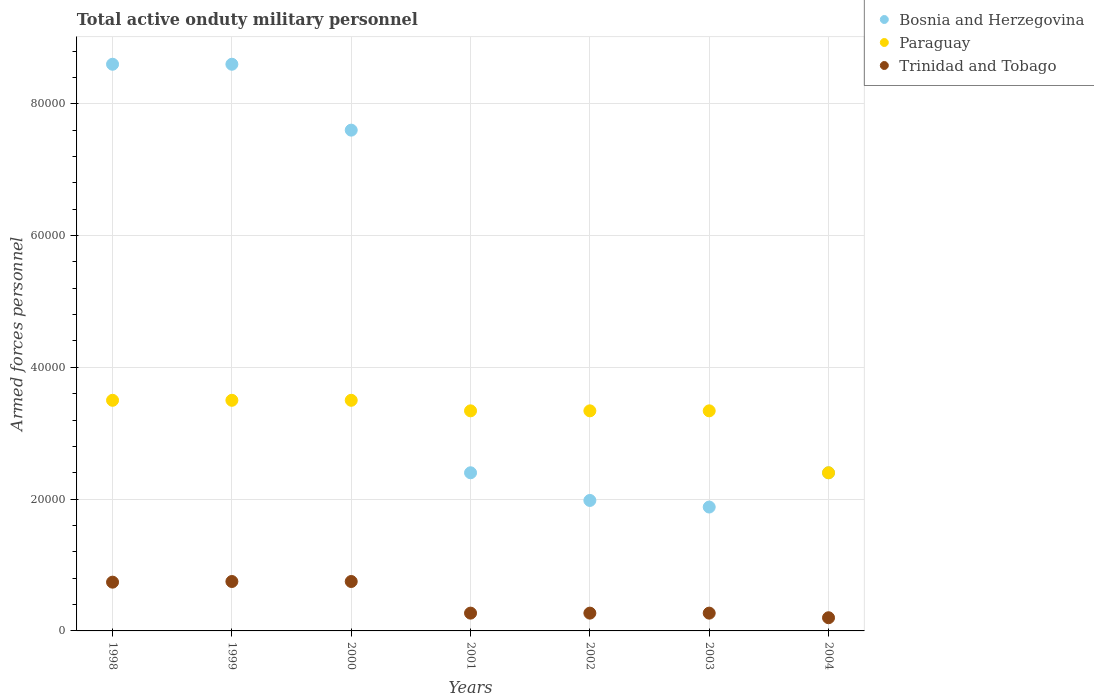What is the number of armed forces personnel in Trinidad and Tobago in 2000?
Offer a very short reply. 7500. Across all years, what is the maximum number of armed forces personnel in Paraguay?
Offer a very short reply. 3.50e+04. Across all years, what is the minimum number of armed forces personnel in Trinidad and Tobago?
Provide a succinct answer. 2000. In which year was the number of armed forces personnel in Paraguay maximum?
Your response must be concise. 1998. In which year was the number of armed forces personnel in Bosnia and Herzegovina minimum?
Provide a succinct answer. 2003. What is the total number of armed forces personnel in Paraguay in the graph?
Keep it short and to the point. 2.29e+05. What is the difference between the number of armed forces personnel in Paraguay in 2000 and that in 2004?
Make the answer very short. 1.10e+04. What is the difference between the number of armed forces personnel in Bosnia and Herzegovina in 1998 and the number of armed forces personnel in Trinidad and Tobago in 2004?
Offer a terse response. 8.40e+04. What is the average number of armed forces personnel in Bosnia and Herzegovina per year?
Give a very brief answer. 4.78e+04. In how many years, is the number of armed forces personnel in Bosnia and Herzegovina greater than 64000?
Your response must be concise. 3. What is the ratio of the number of armed forces personnel in Bosnia and Herzegovina in 2001 to that in 2003?
Offer a terse response. 1.28. Is the number of armed forces personnel in Paraguay in 1998 less than that in 1999?
Ensure brevity in your answer.  No. Is the difference between the number of armed forces personnel in Paraguay in 1999 and 2001 greater than the difference between the number of armed forces personnel in Bosnia and Herzegovina in 1999 and 2001?
Provide a short and direct response. No. What is the difference between the highest and the lowest number of armed forces personnel in Bosnia and Herzegovina?
Your answer should be compact. 6.72e+04. In how many years, is the number of armed forces personnel in Bosnia and Herzegovina greater than the average number of armed forces personnel in Bosnia and Herzegovina taken over all years?
Your answer should be very brief. 3. Does the number of armed forces personnel in Bosnia and Herzegovina monotonically increase over the years?
Offer a terse response. No. Is the number of armed forces personnel in Paraguay strictly greater than the number of armed forces personnel in Bosnia and Herzegovina over the years?
Your answer should be compact. No. How many dotlines are there?
Keep it short and to the point. 3. How many years are there in the graph?
Offer a terse response. 7. Are the values on the major ticks of Y-axis written in scientific E-notation?
Your answer should be very brief. No. Does the graph contain grids?
Your response must be concise. Yes. Where does the legend appear in the graph?
Provide a short and direct response. Top right. How are the legend labels stacked?
Your answer should be very brief. Vertical. What is the title of the graph?
Keep it short and to the point. Total active onduty military personnel. Does "Ethiopia" appear as one of the legend labels in the graph?
Provide a short and direct response. No. What is the label or title of the X-axis?
Your response must be concise. Years. What is the label or title of the Y-axis?
Your answer should be compact. Armed forces personnel. What is the Armed forces personnel of Bosnia and Herzegovina in 1998?
Make the answer very short. 8.60e+04. What is the Armed forces personnel in Paraguay in 1998?
Give a very brief answer. 3.50e+04. What is the Armed forces personnel in Trinidad and Tobago in 1998?
Offer a terse response. 7400. What is the Armed forces personnel of Bosnia and Herzegovina in 1999?
Your answer should be compact. 8.60e+04. What is the Armed forces personnel in Paraguay in 1999?
Your response must be concise. 3.50e+04. What is the Armed forces personnel of Trinidad and Tobago in 1999?
Provide a short and direct response. 7500. What is the Armed forces personnel in Bosnia and Herzegovina in 2000?
Your response must be concise. 7.60e+04. What is the Armed forces personnel of Paraguay in 2000?
Ensure brevity in your answer.  3.50e+04. What is the Armed forces personnel in Trinidad and Tobago in 2000?
Keep it short and to the point. 7500. What is the Armed forces personnel of Bosnia and Herzegovina in 2001?
Give a very brief answer. 2.40e+04. What is the Armed forces personnel of Paraguay in 2001?
Provide a succinct answer. 3.34e+04. What is the Armed forces personnel of Trinidad and Tobago in 2001?
Give a very brief answer. 2700. What is the Armed forces personnel in Bosnia and Herzegovina in 2002?
Offer a terse response. 1.98e+04. What is the Armed forces personnel of Paraguay in 2002?
Provide a short and direct response. 3.34e+04. What is the Armed forces personnel in Trinidad and Tobago in 2002?
Provide a short and direct response. 2700. What is the Armed forces personnel in Bosnia and Herzegovina in 2003?
Provide a succinct answer. 1.88e+04. What is the Armed forces personnel in Paraguay in 2003?
Give a very brief answer. 3.34e+04. What is the Armed forces personnel in Trinidad and Tobago in 2003?
Provide a short and direct response. 2700. What is the Armed forces personnel of Bosnia and Herzegovina in 2004?
Provide a succinct answer. 2.40e+04. What is the Armed forces personnel of Paraguay in 2004?
Offer a terse response. 2.40e+04. Across all years, what is the maximum Armed forces personnel of Bosnia and Herzegovina?
Your response must be concise. 8.60e+04. Across all years, what is the maximum Armed forces personnel in Paraguay?
Give a very brief answer. 3.50e+04. Across all years, what is the maximum Armed forces personnel of Trinidad and Tobago?
Make the answer very short. 7500. Across all years, what is the minimum Armed forces personnel of Bosnia and Herzegovina?
Offer a terse response. 1.88e+04. Across all years, what is the minimum Armed forces personnel in Paraguay?
Provide a short and direct response. 2.40e+04. What is the total Armed forces personnel of Bosnia and Herzegovina in the graph?
Give a very brief answer. 3.35e+05. What is the total Armed forces personnel in Paraguay in the graph?
Your answer should be compact. 2.29e+05. What is the total Armed forces personnel of Trinidad and Tobago in the graph?
Ensure brevity in your answer.  3.25e+04. What is the difference between the Armed forces personnel in Trinidad and Tobago in 1998 and that in 1999?
Make the answer very short. -100. What is the difference between the Armed forces personnel of Bosnia and Herzegovina in 1998 and that in 2000?
Offer a terse response. 10000. What is the difference between the Armed forces personnel in Trinidad and Tobago in 1998 and that in 2000?
Your answer should be very brief. -100. What is the difference between the Armed forces personnel in Bosnia and Herzegovina in 1998 and that in 2001?
Provide a short and direct response. 6.20e+04. What is the difference between the Armed forces personnel in Paraguay in 1998 and that in 2001?
Ensure brevity in your answer.  1600. What is the difference between the Armed forces personnel in Trinidad and Tobago in 1998 and that in 2001?
Offer a terse response. 4700. What is the difference between the Armed forces personnel in Bosnia and Herzegovina in 1998 and that in 2002?
Offer a very short reply. 6.62e+04. What is the difference between the Armed forces personnel of Paraguay in 1998 and that in 2002?
Provide a short and direct response. 1600. What is the difference between the Armed forces personnel in Trinidad and Tobago in 1998 and that in 2002?
Your response must be concise. 4700. What is the difference between the Armed forces personnel of Bosnia and Herzegovina in 1998 and that in 2003?
Provide a short and direct response. 6.72e+04. What is the difference between the Armed forces personnel in Paraguay in 1998 and that in 2003?
Provide a succinct answer. 1600. What is the difference between the Armed forces personnel in Trinidad and Tobago in 1998 and that in 2003?
Your answer should be compact. 4700. What is the difference between the Armed forces personnel in Bosnia and Herzegovina in 1998 and that in 2004?
Your response must be concise. 6.20e+04. What is the difference between the Armed forces personnel of Paraguay in 1998 and that in 2004?
Provide a succinct answer. 1.10e+04. What is the difference between the Armed forces personnel in Trinidad and Tobago in 1998 and that in 2004?
Your answer should be very brief. 5400. What is the difference between the Armed forces personnel of Paraguay in 1999 and that in 2000?
Provide a short and direct response. 0. What is the difference between the Armed forces personnel in Bosnia and Herzegovina in 1999 and that in 2001?
Your answer should be very brief. 6.20e+04. What is the difference between the Armed forces personnel in Paraguay in 1999 and that in 2001?
Your response must be concise. 1600. What is the difference between the Armed forces personnel in Trinidad and Tobago in 1999 and that in 2001?
Make the answer very short. 4800. What is the difference between the Armed forces personnel in Bosnia and Herzegovina in 1999 and that in 2002?
Give a very brief answer. 6.62e+04. What is the difference between the Armed forces personnel in Paraguay in 1999 and that in 2002?
Your answer should be compact. 1600. What is the difference between the Armed forces personnel in Trinidad and Tobago in 1999 and that in 2002?
Make the answer very short. 4800. What is the difference between the Armed forces personnel of Bosnia and Herzegovina in 1999 and that in 2003?
Your answer should be very brief. 6.72e+04. What is the difference between the Armed forces personnel in Paraguay in 1999 and that in 2003?
Your response must be concise. 1600. What is the difference between the Armed forces personnel in Trinidad and Tobago in 1999 and that in 2003?
Offer a very short reply. 4800. What is the difference between the Armed forces personnel in Bosnia and Herzegovina in 1999 and that in 2004?
Make the answer very short. 6.20e+04. What is the difference between the Armed forces personnel of Paraguay in 1999 and that in 2004?
Your answer should be compact. 1.10e+04. What is the difference between the Armed forces personnel of Trinidad and Tobago in 1999 and that in 2004?
Ensure brevity in your answer.  5500. What is the difference between the Armed forces personnel of Bosnia and Herzegovina in 2000 and that in 2001?
Your response must be concise. 5.20e+04. What is the difference between the Armed forces personnel in Paraguay in 2000 and that in 2001?
Your response must be concise. 1600. What is the difference between the Armed forces personnel in Trinidad and Tobago in 2000 and that in 2001?
Provide a succinct answer. 4800. What is the difference between the Armed forces personnel of Bosnia and Herzegovina in 2000 and that in 2002?
Provide a short and direct response. 5.62e+04. What is the difference between the Armed forces personnel of Paraguay in 2000 and that in 2002?
Provide a succinct answer. 1600. What is the difference between the Armed forces personnel in Trinidad and Tobago in 2000 and that in 2002?
Your answer should be very brief. 4800. What is the difference between the Armed forces personnel of Bosnia and Herzegovina in 2000 and that in 2003?
Your answer should be very brief. 5.72e+04. What is the difference between the Armed forces personnel in Paraguay in 2000 and that in 2003?
Offer a terse response. 1600. What is the difference between the Armed forces personnel in Trinidad and Tobago in 2000 and that in 2003?
Provide a succinct answer. 4800. What is the difference between the Armed forces personnel of Bosnia and Herzegovina in 2000 and that in 2004?
Provide a succinct answer. 5.20e+04. What is the difference between the Armed forces personnel of Paraguay in 2000 and that in 2004?
Your answer should be compact. 1.10e+04. What is the difference between the Armed forces personnel in Trinidad and Tobago in 2000 and that in 2004?
Your response must be concise. 5500. What is the difference between the Armed forces personnel of Bosnia and Herzegovina in 2001 and that in 2002?
Provide a short and direct response. 4200. What is the difference between the Armed forces personnel of Paraguay in 2001 and that in 2002?
Provide a short and direct response. 0. What is the difference between the Armed forces personnel of Bosnia and Herzegovina in 2001 and that in 2003?
Offer a terse response. 5200. What is the difference between the Armed forces personnel in Paraguay in 2001 and that in 2003?
Provide a succinct answer. 0. What is the difference between the Armed forces personnel in Paraguay in 2001 and that in 2004?
Offer a very short reply. 9400. What is the difference between the Armed forces personnel of Trinidad and Tobago in 2001 and that in 2004?
Your response must be concise. 700. What is the difference between the Armed forces personnel of Bosnia and Herzegovina in 2002 and that in 2004?
Your response must be concise. -4200. What is the difference between the Armed forces personnel in Paraguay in 2002 and that in 2004?
Give a very brief answer. 9400. What is the difference between the Armed forces personnel in Trinidad and Tobago in 2002 and that in 2004?
Give a very brief answer. 700. What is the difference between the Armed forces personnel of Bosnia and Herzegovina in 2003 and that in 2004?
Offer a terse response. -5200. What is the difference between the Armed forces personnel in Paraguay in 2003 and that in 2004?
Provide a short and direct response. 9400. What is the difference between the Armed forces personnel in Trinidad and Tobago in 2003 and that in 2004?
Provide a short and direct response. 700. What is the difference between the Armed forces personnel in Bosnia and Herzegovina in 1998 and the Armed forces personnel in Paraguay in 1999?
Your response must be concise. 5.10e+04. What is the difference between the Armed forces personnel of Bosnia and Herzegovina in 1998 and the Armed forces personnel of Trinidad and Tobago in 1999?
Provide a succinct answer. 7.85e+04. What is the difference between the Armed forces personnel of Paraguay in 1998 and the Armed forces personnel of Trinidad and Tobago in 1999?
Your answer should be very brief. 2.75e+04. What is the difference between the Armed forces personnel in Bosnia and Herzegovina in 1998 and the Armed forces personnel in Paraguay in 2000?
Provide a succinct answer. 5.10e+04. What is the difference between the Armed forces personnel in Bosnia and Herzegovina in 1998 and the Armed forces personnel in Trinidad and Tobago in 2000?
Your answer should be compact. 7.85e+04. What is the difference between the Armed forces personnel in Paraguay in 1998 and the Armed forces personnel in Trinidad and Tobago in 2000?
Offer a terse response. 2.75e+04. What is the difference between the Armed forces personnel in Bosnia and Herzegovina in 1998 and the Armed forces personnel in Paraguay in 2001?
Provide a succinct answer. 5.26e+04. What is the difference between the Armed forces personnel of Bosnia and Herzegovina in 1998 and the Armed forces personnel of Trinidad and Tobago in 2001?
Provide a succinct answer. 8.33e+04. What is the difference between the Armed forces personnel in Paraguay in 1998 and the Armed forces personnel in Trinidad and Tobago in 2001?
Provide a succinct answer. 3.23e+04. What is the difference between the Armed forces personnel of Bosnia and Herzegovina in 1998 and the Armed forces personnel of Paraguay in 2002?
Your response must be concise. 5.26e+04. What is the difference between the Armed forces personnel in Bosnia and Herzegovina in 1998 and the Armed forces personnel in Trinidad and Tobago in 2002?
Offer a very short reply. 8.33e+04. What is the difference between the Armed forces personnel of Paraguay in 1998 and the Armed forces personnel of Trinidad and Tobago in 2002?
Your answer should be very brief. 3.23e+04. What is the difference between the Armed forces personnel in Bosnia and Herzegovina in 1998 and the Armed forces personnel in Paraguay in 2003?
Your response must be concise. 5.26e+04. What is the difference between the Armed forces personnel of Bosnia and Herzegovina in 1998 and the Armed forces personnel of Trinidad and Tobago in 2003?
Your response must be concise. 8.33e+04. What is the difference between the Armed forces personnel in Paraguay in 1998 and the Armed forces personnel in Trinidad and Tobago in 2003?
Ensure brevity in your answer.  3.23e+04. What is the difference between the Armed forces personnel of Bosnia and Herzegovina in 1998 and the Armed forces personnel of Paraguay in 2004?
Make the answer very short. 6.20e+04. What is the difference between the Armed forces personnel of Bosnia and Herzegovina in 1998 and the Armed forces personnel of Trinidad and Tobago in 2004?
Ensure brevity in your answer.  8.40e+04. What is the difference between the Armed forces personnel in Paraguay in 1998 and the Armed forces personnel in Trinidad and Tobago in 2004?
Offer a very short reply. 3.30e+04. What is the difference between the Armed forces personnel in Bosnia and Herzegovina in 1999 and the Armed forces personnel in Paraguay in 2000?
Keep it short and to the point. 5.10e+04. What is the difference between the Armed forces personnel of Bosnia and Herzegovina in 1999 and the Armed forces personnel of Trinidad and Tobago in 2000?
Provide a short and direct response. 7.85e+04. What is the difference between the Armed forces personnel in Paraguay in 1999 and the Armed forces personnel in Trinidad and Tobago in 2000?
Provide a short and direct response. 2.75e+04. What is the difference between the Armed forces personnel in Bosnia and Herzegovina in 1999 and the Armed forces personnel in Paraguay in 2001?
Give a very brief answer. 5.26e+04. What is the difference between the Armed forces personnel of Bosnia and Herzegovina in 1999 and the Armed forces personnel of Trinidad and Tobago in 2001?
Your response must be concise. 8.33e+04. What is the difference between the Armed forces personnel of Paraguay in 1999 and the Armed forces personnel of Trinidad and Tobago in 2001?
Give a very brief answer. 3.23e+04. What is the difference between the Armed forces personnel in Bosnia and Herzegovina in 1999 and the Armed forces personnel in Paraguay in 2002?
Your response must be concise. 5.26e+04. What is the difference between the Armed forces personnel in Bosnia and Herzegovina in 1999 and the Armed forces personnel in Trinidad and Tobago in 2002?
Keep it short and to the point. 8.33e+04. What is the difference between the Armed forces personnel of Paraguay in 1999 and the Armed forces personnel of Trinidad and Tobago in 2002?
Ensure brevity in your answer.  3.23e+04. What is the difference between the Armed forces personnel in Bosnia and Herzegovina in 1999 and the Armed forces personnel in Paraguay in 2003?
Your answer should be very brief. 5.26e+04. What is the difference between the Armed forces personnel in Bosnia and Herzegovina in 1999 and the Armed forces personnel in Trinidad and Tobago in 2003?
Keep it short and to the point. 8.33e+04. What is the difference between the Armed forces personnel of Paraguay in 1999 and the Armed forces personnel of Trinidad and Tobago in 2003?
Provide a succinct answer. 3.23e+04. What is the difference between the Armed forces personnel in Bosnia and Herzegovina in 1999 and the Armed forces personnel in Paraguay in 2004?
Your response must be concise. 6.20e+04. What is the difference between the Armed forces personnel in Bosnia and Herzegovina in 1999 and the Armed forces personnel in Trinidad and Tobago in 2004?
Your answer should be very brief. 8.40e+04. What is the difference between the Armed forces personnel of Paraguay in 1999 and the Armed forces personnel of Trinidad and Tobago in 2004?
Your answer should be compact. 3.30e+04. What is the difference between the Armed forces personnel of Bosnia and Herzegovina in 2000 and the Armed forces personnel of Paraguay in 2001?
Make the answer very short. 4.26e+04. What is the difference between the Armed forces personnel in Bosnia and Herzegovina in 2000 and the Armed forces personnel in Trinidad and Tobago in 2001?
Your answer should be very brief. 7.33e+04. What is the difference between the Armed forces personnel of Paraguay in 2000 and the Armed forces personnel of Trinidad and Tobago in 2001?
Your response must be concise. 3.23e+04. What is the difference between the Armed forces personnel in Bosnia and Herzegovina in 2000 and the Armed forces personnel in Paraguay in 2002?
Keep it short and to the point. 4.26e+04. What is the difference between the Armed forces personnel in Bosnia and Herzegovina in 2000 and the Armed forces personnel in Trinidad and Tobago in 2002?
Keep it short and to the point. 7.33e+04. What is the difference between the Armed forces personnel of Paraguay in 2000 and the Armed forces personnel of Trinidad and Tobago in 2002?
Your response must be concise. 3.23e+04. What is the difference between the Armed forces personnel in Bosnia and Herzegovina in 2000 and the Armed forces personnel in Paraguay in 2003?
Your response must be concise. 4.26e+04. What is the difference between the Armed forces personnel in Bosnia and Herzegovina in 2000 and the Armed forces personnel in Trinidad and Tobago in 2003?
Your response must be concise. 7.33e+04. What is the difference between the Armed forces personnel of Paraguay in 2000 and the Armed forces personnel of Trinidad and Tobago in 2003?
Your answer should be very brief. 3.23e+04. What is the difference between the Armed forces personnel of Bosnia and Herzegovina in 2000 and the Armed forces personnel of Paraguay in 2004?
Offer a very short reply. 5.20e+04. What is the difference between the Armed forces personnel in Bosnia and Herzegovina in 2000 and the Armed forces personnel in Trinidad and Tobago in 2004?
Make the answer very short. 7.40e+04. What is the difference between the Armed forces personnel in Paraguay in 2000 and the Armed forces personnel in Trinidad and Tobago in 2004?
Your response must be concise. 3.30e+04. What is the difference between the Armed forces personnel of Bosnia and Herzegovina in 2001 and the Armed forces personnel of Paraguay in 2002?
Your answer should be very brief. -9400. What is the difference between the Armed forces personnel of Bosnia and Herzegovina in 2001 and the Armed forces personnel of Trinidad and Tobago in 2002?
Give a very brief answer. 2.13e+04. What is the difference between the Armed forces personnel in Paraguay in 2001 and the Armed forces personnel in Trinidad and Tobago in 2002?
Your answer should be compact. 3.07e+04. What is the difference between the Armed forces personnel of Bosnia and Herzegovina in 2001 and the Armed forces personnel of Paraguay in 2003?
Ensure brevity in your answer.  -9400. What is the difference between the Armed forces personnel of Bosnia and Herzegovina in 2001 and the Armed forces personnel of Trinidad and Tobago in 2003?
Keep it short and to the point. 2.13e+04. What is the difference between the Armed forces personnel in Paraguay in 2001 and the Armed forces personnel in Trinidad and Tobago in 2003?
Ensure brevity in your answer.  3.07e+04. What is the difference between the Armed forces personnel in Bosnia and Herzegovina in 2001 and the Armed forces personnel in Trinidad and Tobago in 2004?
Provide a short and direct response. 2.20e+04. What is the difference between the Armed forces personnel in Paraguay in 2001 and the Armed forces personnel in Trinidad and Tobago in 2004?
Make the answer very short. 3.14e+04. What is the difference between the Armed forces personnel of Bosnia and Herzegovina in 2002 and the Armed forces personnel of Paraguay in 2003?
Offer a terse response. -1.36e+04. What is the difference between the Armed forces personnel in Bosnia and Herzegovina in 2002 and the Armed forces personnel in Trinidad and Tobago in 2003?
Ensure brevity in your answer.  1.71e+04. What is the difference between the Armed forces personnel in Paraguay in 2002 and the Armed forces personnel in Trinidad and Tobago in 2003?
Your response must be concise. 3.07e+04. What is the difference between the Armed forces personnel of Bosnia and Herzegovina in 2002 and the Armed forces personnel of Paraguay in 2004?
Provide a succinct answer. -4200. What is the difference between the Armed forces personnel in Bosnia and Herzegovina in 2002 and the Armed forces personnel in Trinidad and Tobago in 2004?
Your answer should be compact. 1.78e+04. What is the difference between the Armed forces personnel of Paraguay in 2002 and the Armed forces personnel of Trinidad and Tobago in 2004?
Ensure brevity in your answer.  3.14e+04. What is the difference between the Armed forces personnel in Bosnia and Herzegovina in 2003 and the Armed forces personnel in Paraguay in 2004?
Ensure brevity in your answer.  -5200. What is the difference between the Armed forces personnel in Bosnia and Herzegovina in 2003 and the Armed forces personnel in Trinidad and Tobago in 2004?
Provide a short and direct response. 1.68e+04. What is the difference between the Armed forces personnel in Paraguay in 2003 and the Armed forces personnel in Trinidad and Tobago in 2004?
Your answer should be compact. 3.14e+04. What is the average Armed forces personnel of Bosnia and Herzegovina per year?
Offer a very short reply. 4.78e+04. What is the average Armed forces personnel in Paraguay per year?
Keep it short and to the point. 3.27e+04. What is the average Armed forces personnel of Trinidad and Tobago per year?
Your response must be concise. 4642.86. In the year 1998, what is the difference between the Armed forces personnel of Bosnia and Herzegovina and Armed forces personnel of Paraguay?
Offer a terse response. 5.10e+04. In the year 1998, what is the difference between the Armed forces personnel of Bosnia and Herzegovina and Armed forces personnel of Trinidad and Tobago?
Your answer should be very brief. 7.86e+04. In the year 1998, what is the difference between the Armed forces personnel of Paraguay and Armed forces personnel of Trinidad and Tobago?
Your response must be concise. 2.76e+04. In the year 1999, what is the difference between the Armed forces personnel in Bosnia and Herzegovina and Armed forces personnel in Paraguay?
Offer a terse response. 5.10e+04. In the year 1999, what is the difference between the Armed forces personnel in Bosnia and Herzegovina and Armed forces personnel in Trinidad and Tobago?
Offer a very short reply. 7.85e+04. In the year 1999, what is the difference between the Armed forces personnel in Paraguay and Armed forces personnel in Trinidad and Tobago?
Provide a short and direct response. 2.75e+04. In the year 2000, what is the difference between the Armed forces personnel in Bosnia and Herzegovina and Armed forces personnel in Paraguay?
Ensure brevity in your answer.  4.10e+04. In the year 2000, what is the difference between the Armed forces personnel in Bosnia and Herzegovina and Armed forces personnel in Trinidad and Tobago?
Your answer should be compact. 6.85e+04. In the year 2000, what is the difference between the Armed forces personnel in Paraguay and Armed forces personnel in Trinidad and Tobago?
Your response must be concise. 2.75e+04. In the year 2001, what is the difference between the Armed forces personnel in Bosnia and Herzegovina and Armed forces personnel in Paraguay?
Provide a succinct answer. -9400. In the year 2001, what is the difference between the Armed forces personnel of Bosnia and Herzegovina and Armed forces personnel of Trinidad and Tobago?
Make the answer very short. 2.13e+04. In the year 2001, what is the difference between the Armed forces personnel of Paraguay and Armed forces personnel of Trinidad and Tobago?
Ensure brevity in your answer.  3.07e+04. In the year 2002, what is the difference between the Armed forces personnel of Bosnia and Herzegovina and Armed forces personnel of Paraguay?
Your response must be concise. -1.36e+04. In the year 2002, what is the difference between the Armed forces personnel of Bosnia and Herzegovina and Armed forces personnel of Trinidad and Tobago?
Offer a very short reply. 1.71e+04. In the year 2002, what is the difference between the Armed forces personnel in Paraguay and Armed forces personnel in Trinidad and Tobago?
Offer a terse response. 3.07e+04. In the year 2003, what is the difference between the Armed forces personnel of Bosnia and Herzegovina and Armed forces personnel of Paraguay?
Provide a succinct answer. -1.46e+04. In the year 2003, what is the difference between the Armed forces personnel of Bosnia and Herzegovina and Armed forces personnel of Trinidad and Tobago?
Keep it short and to the point. 1.61e+04. In the year 2003, what is the difference between the Armed forces personnel in Paraguay and Armed forces personnel in Trinidad and Tobago?
Ensure brevity in your answer.  3.07e+04. In the year 2004, what is the difference between the Armed forces personnel of Bosnia and Herzegovina and Armed forces personnel of Paraguay?
Keep it short and to the point. 0. In the year 2004, what is the difference between the Armed forces personnel in Bosnia and Herzegovina and Armed forces personnel in Trinidad and Tobago?
Offer a very short reply. 2.20e+04. In the year 2004, what is the difference between the Armed forces personnel in Paraguay and Armed forces personnel in Trinidad and Tobago?
Make the answer very short. 2.20e+04. What is the ratio of the Armed forces personnel of Bosnia and Herzegovina in 1998 to that in 1999?
Your answer should be compact. 1. What is the ratio of the Armed forces personnel in Trinidad and Tobago in 1998 to that in 1999?
Give a very brief answer. 0.99. What is the ratio of the Armed forces personnel of Bosnia and Herzegovina in 1998 to that in 2000?
Give a very brief answer. 1.13. What is the ratio of the Armed forces personnel in Paraguay in 1998 to that in 2000?
Your response must be concise. 1. What is the ratio of the Armed forces personnel in Trinidad and Tobago in 1998 to that in 2000?
Give a very brief answer. 0.99. What is the ratio of the Armed forces personnel in Bosnia and Herzegovina in 1998 to that in 2001?
Offer a very short reply. 3.58. What is the ratio of the Armed forces personnel of Paraguay in 1998 to that in 2001?
Your response must be concise. 1.05. What is the ratio of the Armed forces personnel in Trinidad and Tobago in 1998 to that in 2001?
Make the answer very short. 2.74. What is the ratio of the Armed forces personnel of Bosnia and Herzegovina in 1998 to that in 2002?
Your answer should be compact. 4.34. What is the ratio of the Armed forces personnel of Paraguay in 1998 to that in 2002?
Keep it short and to the point. 1.05. What is the ratio of the Armed forces personnel in Trinidad and Tobago in 1998 to that in 2002?
Provide a succinct answer. 2.74. What is the ratio of the Armed forces personnel in Bosnia and Herzegovina in 1998 to that in 2003?
Offer a terse response. 4.57. What is the ratio of the Armed forces personnel of Paraguay in 1998 to that in 2003?
Offer a very short reply. 1.05. What is the ratio of the Armed forces personnel in Trinidad and Tobago in 1998 to that in 2003?
Provide a succinct answer. 2.74. What is the ratio of the Armed forces personnel in Bosnia and Herzegovina in 1998 to that in 2004?
Your response must be concise. 3.58. What is the ratio of the Armed forces personnel of Paraguay in 1998 to that in 2004?
Your response must be concise. 1.46. What is the ratio of the Armed forces personnel of Bosnia and Herzegovina in 1999 to that in 2000?
Make the answer very short. 1.13. What is the ratio of the Armed forces personnel of Bosnia and Herzegovina in 1999 to that in 2001?
Provide a succinct answer. 3.58. What is the ratio of the Armed forces personnel in Paraguay in 1999 to that in 2001?
Your answer should be compact. 1.05. What is the ratio of the Armed forces personnel of Trinidad and Tobago in 1999 to that in 2001?
Your response must be concise. 2.78. What is the ratio of the Armed forces personnel of Bosnia and Herzegovina in 1999 to that in 2002?
Offer a terse response. 4.34. What is the ratio of the Armed forces personnel in Paraguay in 1999 to that in 2002?
Your response must be concise. 1.05. What is the ratio of the Armed forces personnel in Trinidad and Tobago in 1999 to that in 2002?
Ensure brevity in your answer.  2.78. What is the ratio of the Armed forces personnel of Bosnia and Herzegovina in 1999 to that in 2003?
Keep it short and to the point. 4.57. What is the ratio of the Armed forces personnel in Paraguay in 1999 to that in 2003?
Provide a succinct answer. 1.05. What is the ratio of the Armed forces personnel in Trinidad and Tobago in 1999 to that in 2003?
Make the answer very short. 2.78. What is the ratio of the Armed forces personnel in Bosnia and Herzegovina in 1999 to that in 2004?
Give a very brief answer. 3.58. What is the ratio of the Armed forces personnel in Paraguay in 1999 to that in 2004?
Your answer should be compact. 1.46. What is the ratio of the Armed forces personnel in Trinidad and Tobago in 1999 to that in 2004?
Give a very brief answer. 3.75. What is the ratio of the Armed forces personnel in Bosnia and Herzegovina in 2000 to that in 2001?
Ensure brevity in your answer.  3.17. What is the ratio of the Armed forces personnel in Paraguay in 2000 to that in 2001?
Make the answer very short. 1.05. What is the ratio of the Armed forces personnel in Trinidad and Tobago in 2000 to that in 2001?
Keep it short and to the point. 2.78. What is the ratio of the Armed forces personnel in Bosnia and Herzegovina in 2000 to that in 2002?
Your response must be concise. 3.84. What is the ratio of the Armed forces personnel of Paraguay in 2000 to that in 2002?
Keep it short and to the point. 1.05. What is the ratio of the Armed forces personnel in Trinidad and Tobago in 2000 to that in 2002?
Provide a short and direct response. 2.78. What is the ratio of the Armed forces personnel in Bosnia and Herzegovina in 2000 to that in 2003?
Ensure brevity in your answer.  4.04. What is the ratio of the Armed forces personnel in Paraguay in 2000 to that in 2003?
Provide a succinct answer. 1.05. What is the ratio of the Armed forces personnel of Trinidad and Tobago in 2000 to that in 2003?
Offer a very short reply. 2.78. What is the ratio of the Armed forces personnel in Bosnia and Herzegovina in 2000 to that in 2004?
Your answer should be very brief. 3.17. What is the ratio of the Armed forces personnel of Paraguay in 2000 to that in 2004?
Provide a succinct answer. 1.46. What is the ratio of the Armed forces personnel in Trinidad and Tobago in 2000 to that in 2004?
Offer a terse response. 3.75. What is the ratio of the Armed forces personnel of Bosnia and Herzegovina in 2001 to that in 2002?
Your answer should be compact. 1.21. What is the ratio of the Armed forces personnel of Bosnia and Herzegovina in 2001 to that in 2003?
Provide a short and direct response. 1.28. What is the ratio of the Armed forces personnel of Paraguay in 2001 to that in 2004?
Offer a terse response. 1.39. What is the ratio of the Armed forces personnel of Trinidad and Tobago in 2001 to that in 2004?
Provide a short and direct response. 1.35. What is the ratio of the Armed forces personnel of Bosnia and Herzegovina in 2002 to that in 2003?
Your answer should be very brief. 1.05. What is the ratio of the Armed forces personnel in Paraguay in 2002 to that in 2003?
Your answer should be very brief. 1. What is the ratio of the Armed forces personnel in Bosnia and Herzegovina in 2002 to that in 2004?
Offer a very short reply. 0.82. What is the ratio of the Armed forces personnel of Paraguay in 2002 to that in 2004?
Give a very brief answer. 1.39. What is the ratio of the Armed forces personnel of Trinidad and Tobago in 2002 to that in 2004?
Provide a short and direct response. 1.35. What is the ratio of the Armed forces personnel of Bosnia and Herzegovina in 2003 to that in 2004?
Give a very brief answer. 0.78. What is the ratio of the Armed forces personnel in Paraguay in 2003 to that in 2004?
Keep it short and to the point. 1.39. What is the ratio of the Armed forces personnel of Trinidad and Tobago in 2003 to that in 2004?
Provide a succinct answer. 1.35. What is the difference between the highest and the second highest Armed forces personnel in Trinidad and Tobago?
Your response must be concise. 0. What is the difference between the highest and the lowest Armed forces personnel of Bosnia and Herzegovina?
Offer a terse response. 6.72e+04. What is the difference between the highest and the lowest Armed forces personnel in Paraguay?
Offer a very short reply. 1.10e+04. What is the difference between the highest and the lowest Armed forces personnel of Trinidad and Tobago?
Your response must be concise. 5500. 